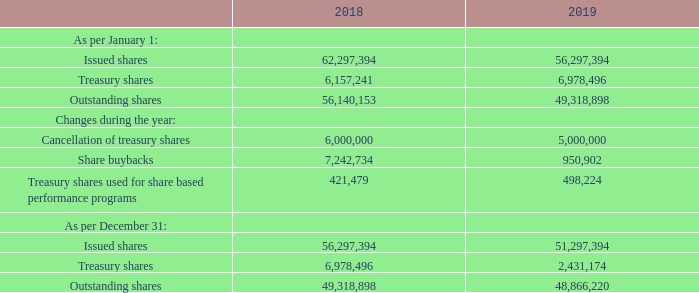TREASURY SHARES
On December 31, 2019, we had 48,866,220 outstanding common shares excluding 2,431,174 treasury shares. This compared to 49,318,898 outstanding common shares and 6,978,496 treasury shares at year-end 2018. Besides the cancellation of 5 million treasury shares in July 2019, the change in the number of treasury shares in 2019 was the result of approximately 950,000 repurchased shares and approximately 498,000 treasury shares that were used as part of share based payments.
What was the reason for the change in the number of treasury shares in 2019? The result of approximately 950,000 repurchased shares and approximately 498,000 treasury shares that were used as part of share based payments. What is the number of outstanding common shares on December 31, 2019? 48,866,220. What is the Cancellation of treasury shares for 2019? 5,000,000. What is the  Outstanding shares expressed as a ratio of  Issued shares for december 2019?  48,866,220/51,297,394
Answer: 0.95. What is the percentage change in  Share buybacks from during the year 2018 to during the year 2019?
Answer scale should be: percent.  (950,902-7,242,734)/ 7,242,734
Answer: -86.87. What is the percentage change in outstanding shares  As per December 31 from 2018 to 2019?
Answer scale should be: percent. (48,866,220- 49,318,898)/ 49,318,898
Answer: -0.92. 